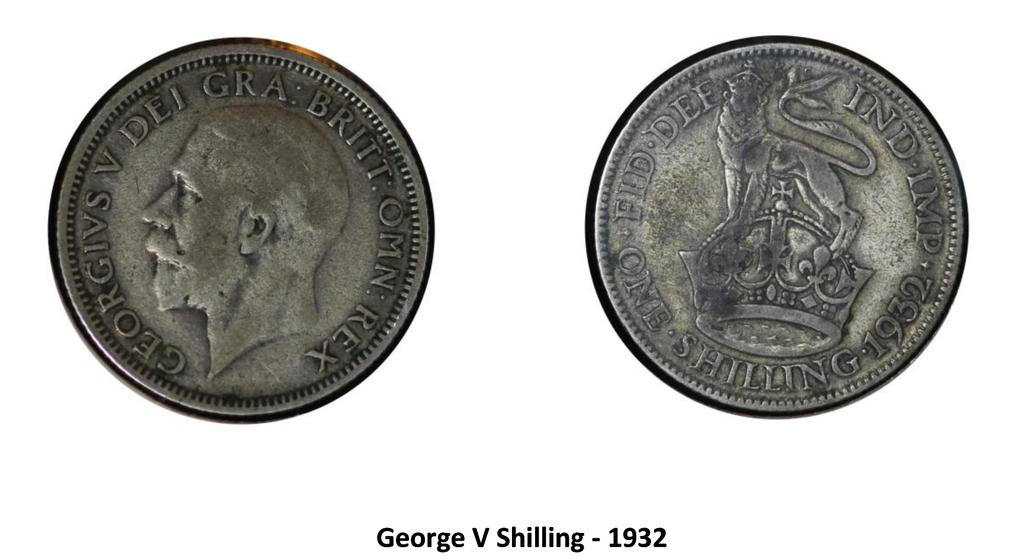<image>
Present a compact description of the photo's key features. 2 coins from 1932 one is called george the other is called shilling 